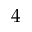Convert formula to latex. <formula><loc_0><loc_0><loc_500><loc_500>4</formula> 